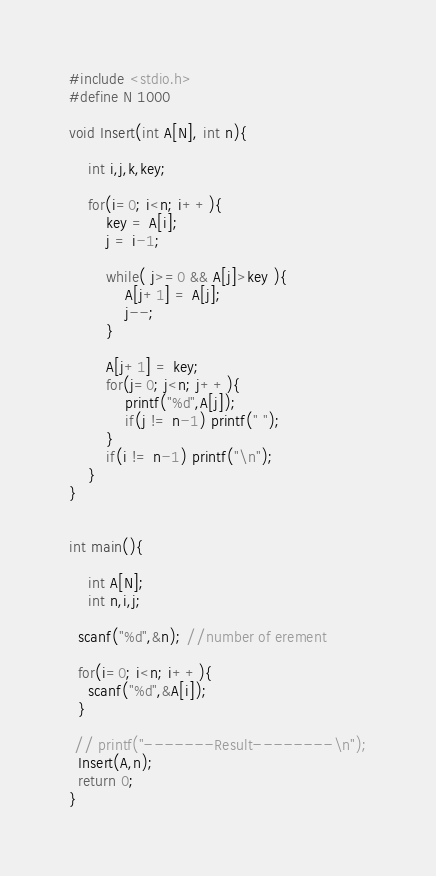Convert code to text. <code><loc_0><loc_0><loc_500><loc_500><_C_>#include <stdio.h>
#define N 1000

void Insert(int A[N], int n){

	int i,j,k,key;

	for(i=0; i<n; i++){
		key = A[i];
		j = i-1;

		while( j>=0 && A[j]>key ){
			A[j+1] = A[j];
			j--;
		}

		A[j+1] = key;
		for(j=0; j<n; j++){
			printf("%d",A[j]);
			if(j != n-1) printf(" ");
		}
		if(i != n-1) printf("\n");
	}
}


int main(){

	int A[N];
	int n,i,j;

  scanf("%d",&n); //number of erement

  for(i=0; i<n; i++){
  	scanf("%d",&A[i]);
  }

 // printf("-------Result--------\n");
  Insert(A,n);
  return 0;
}

</code> 